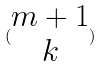Convert formula to latex. <formula><loc_0><loc_0><loc_500><loc_500>( \begin{matrix} m + 1 \\ k \end{matrix} )</formula> 